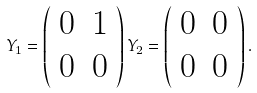<formula> <loc_0><loc_0><loc_500><loc_500>Y _ { 1 } = \left ( \begin{array} { c c } 0 & 1 \\ 0 & 0 \end{array} \right ) Y _ { 2 } = \left ( \begin{array} { c c } 0 & 0 \\ 0 & 0 \end{array} \right ) .</formula> 